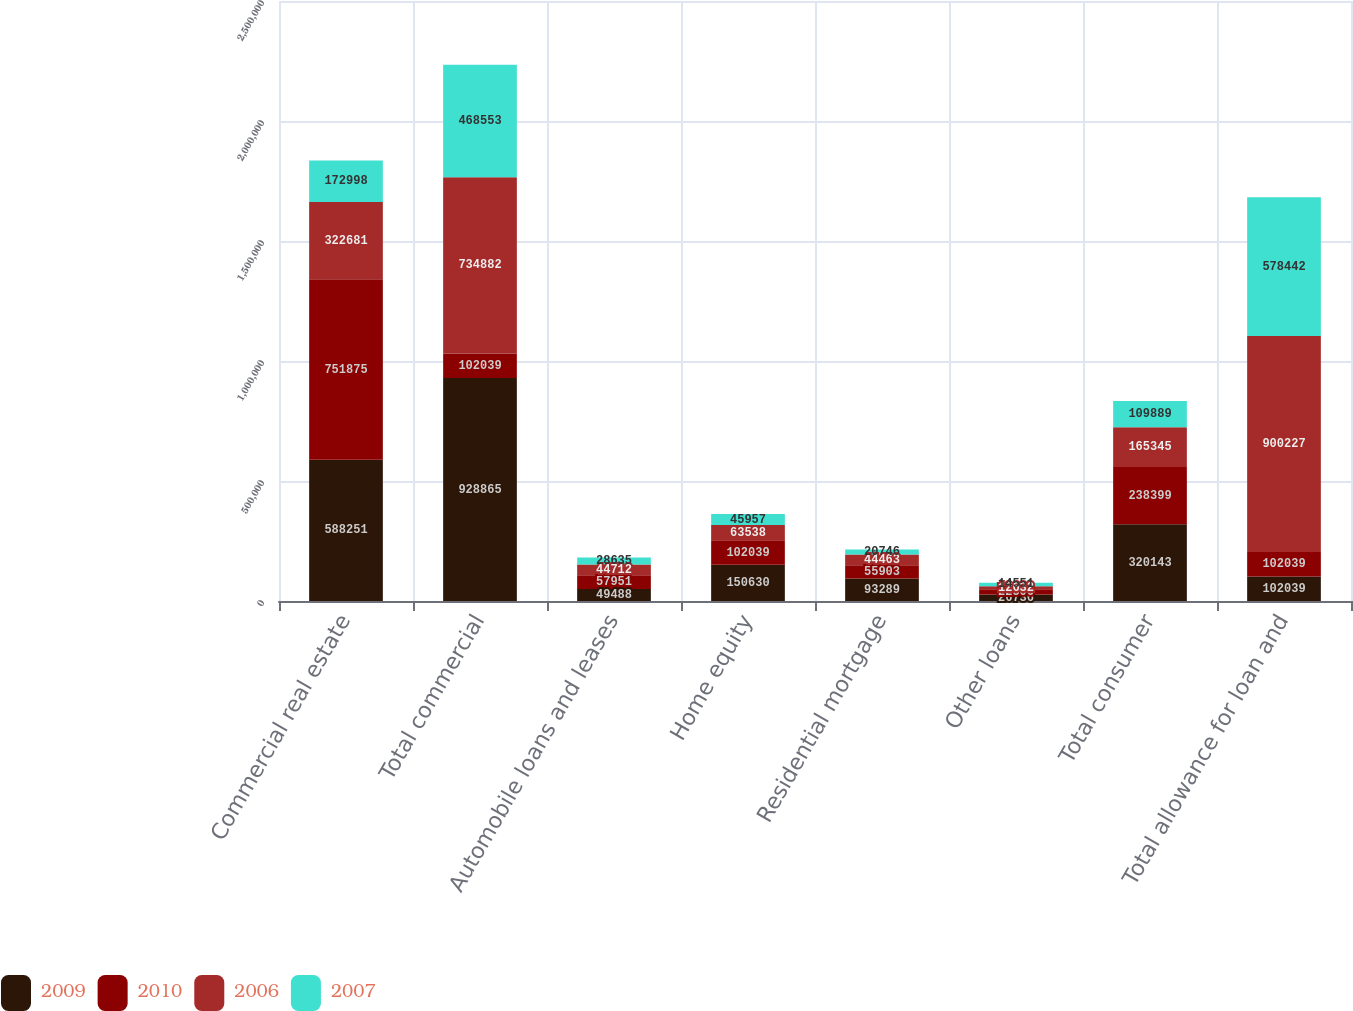Convert chart. <chart><loc_0><loc_0><loc_500><loc_500><stacked_bar_chart><ecel><fcel>Commercial real estate<fcel>Total commercial<fcel>Automobile loans and leases<fcel>Home equity<fcel>Residential mortgage<fcel>Other loans<fcel>Total consumer<fcel>Total allowance for loan and<nl><fcel>2009<fcel>588251<fcel>928865<fcel>49488<fcel>150630<fcel>93289<fcel>26736<fcel>320143<fcel>102039<nl><fcel>2010<fcel>751875<fcel>102039<fcel>57951<fcel>102039<fcel>55903<fcel>22506<fcel>238399<fcel>102039<nl><fcel>2006<fcel>322681<fcel>734882<fcel>44712<fcel>63538<fcel>44463<fcel>12632<fcel>165345<fcel>900227<nl><fcel>2007<fcel>172998<fcel>468553<fcel>28635<fcel>45957<fcel>20746<fcel>14551<fcel>109889<fcel>578442<nl></chart> 